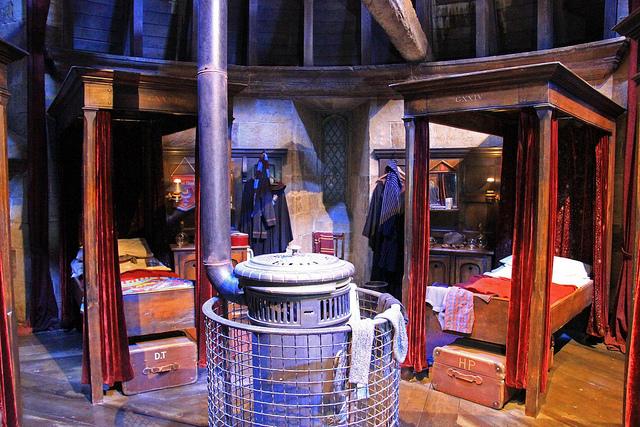What is the pipe that leads up to the ceiling for?
Short answer required. Exhaust. Is the trunk on the left monogrammed?
Keep it brief. Yes. What movie is this from?
Concise answer only. Harry potter. 